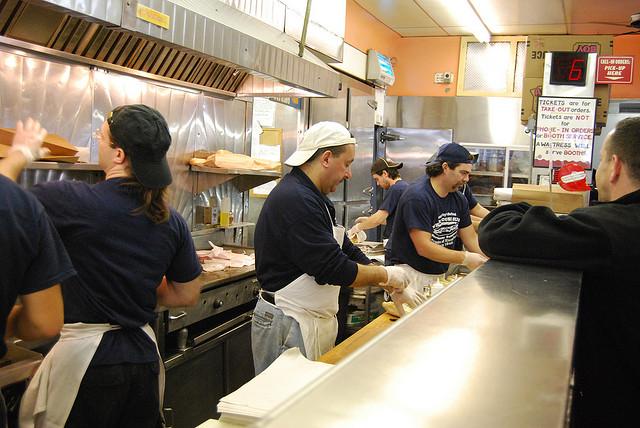What number is on the sign?
Keep it brief. 6. How many people are working behind the counter?
Give a very brief answer. 5. Is everyone behind the counter wearing an apron?
Short answer required. Yes. 